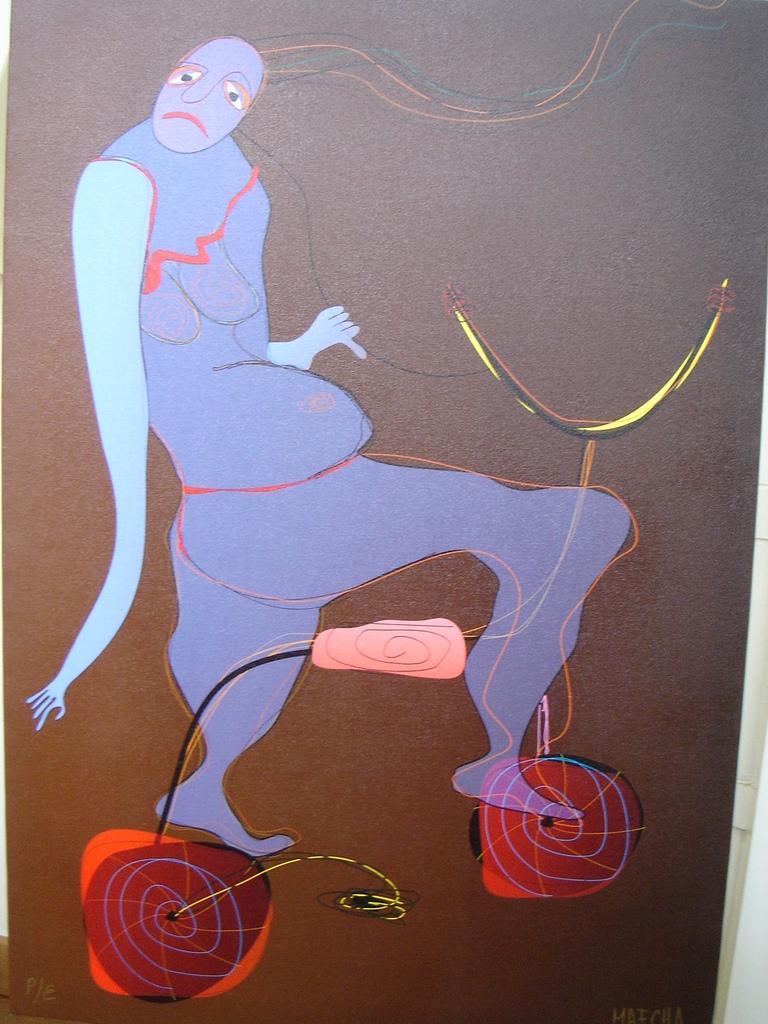Can you describe this image briefly? In this image I can see an art of the person. I can see the brown color background. 